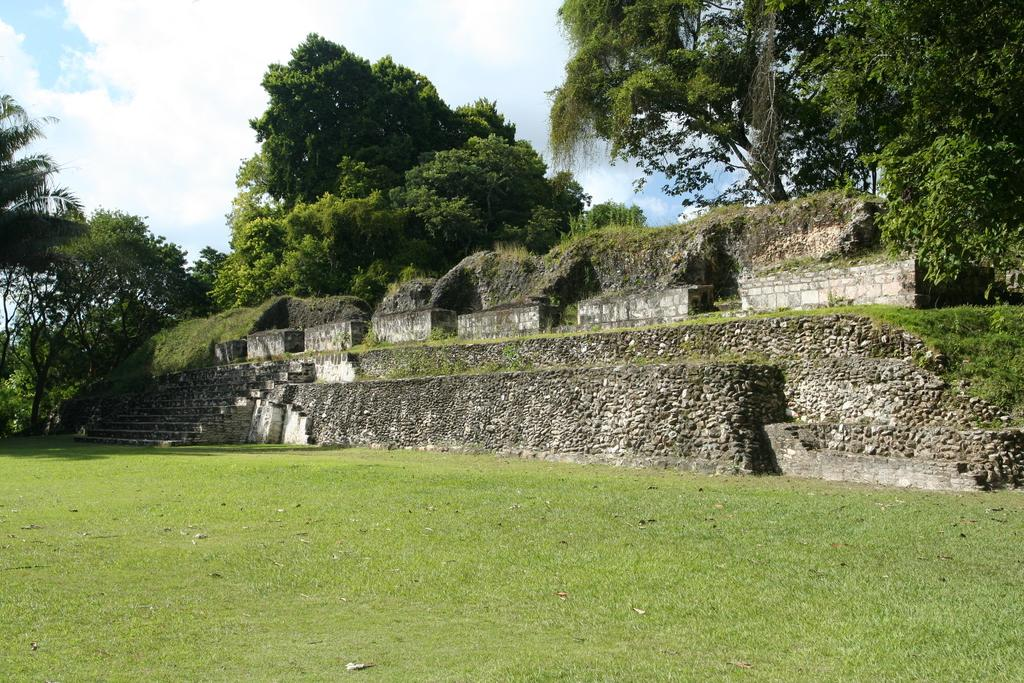What type of vegetation is present in the image? There is grass in the image. What type of structures can be seen in the image? There are walls and steps in the image. What other natural elements are visible in the image? There are trees in the image. What can be seen in the background of the image? The sky is visible in the background of the image. What type of reward is being given to the trees in the image? There is no reward being given to the trees in the image; they are simply part of the natural landscape. What time does the clock in the image indicate? There is no clock present in the image. 